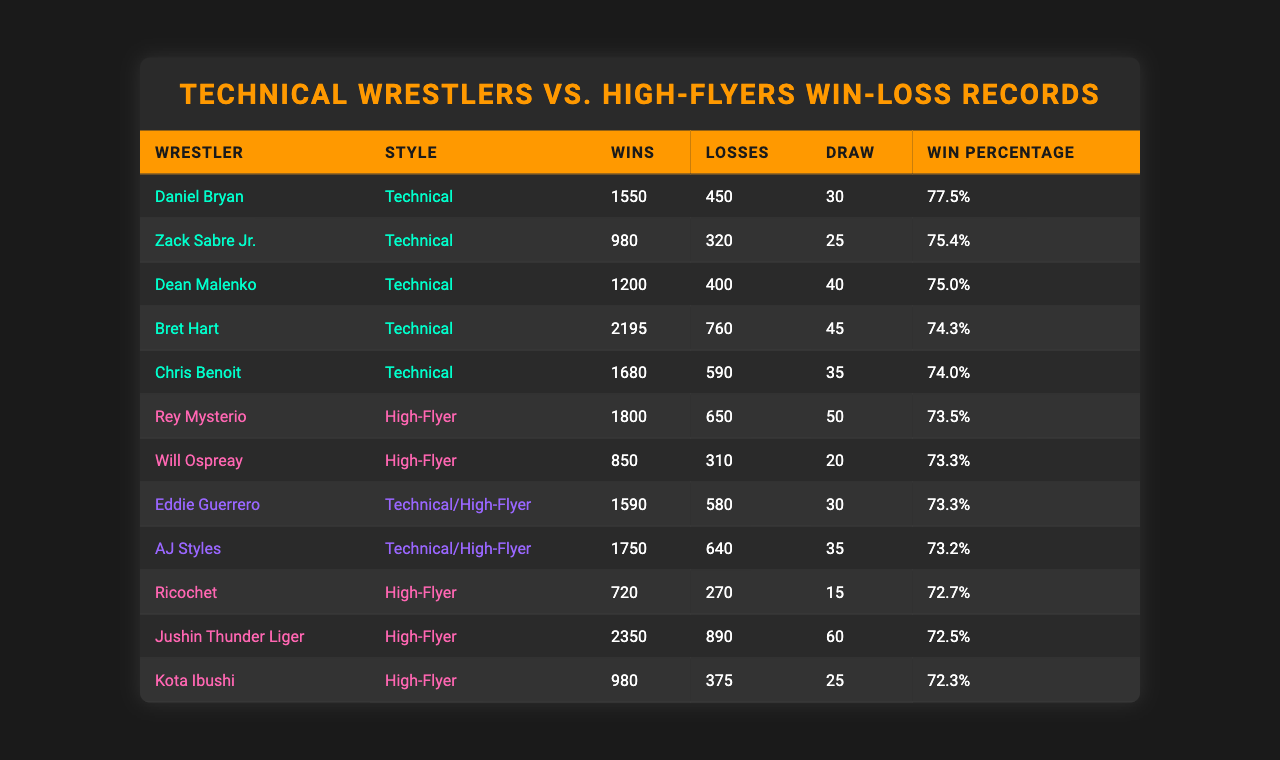What is the win percentage of Daniel Bryan? The table lists Daniel Bryan's win percentage as 77.5% under the "Win Percentage" column.
Answer: 77.5% Which wrestler has the highest number of losses? Jushin Thunder Liger has the highest number of losses at 890 as shown in the "Losses" column.
Answer: 890 Calculate the average win percentage of Technical wrestlers. The win percentages for Technical wrestlers are 77.5, 75.4, 75.0, 74.3, and 74.0. The sum is 376.2 and dividing by 5 gives an average of 75.24.
Answer: 75.24 Is the win percentage of high-flyers generally lower than that of technical wrestlers? Comparing the win percentages: Technical wrestlers have percentages mostly in the mid to high 70s while high-flyers are mostly in the low to mid 70s indicating low win percentages. Hence, it is generally true.
Answer: Yes If you combine the wins of all technical wrestlers, how many wins do they have in total? Adding the wins of all technical wrestlers: 1550 + 980 + 1200 + 2195 + 1680 = 8105 wins in total.
Answer: 8105 Who has a higher win-loss ratio, Bret Hart or Rey Mysterio? Bret Hart's win-loss ratio is calculated by dividing wins (2195) by losses (760), giving approximately 2.89. Rey Mysterio's win-loss ratio is 1800/650, approximately 2.77. Therefore, Bret Hart has a higher ratio.
Answer: Bret Hart What is the difference in the number of wins between the highest-rated technical wrestler and the highest-rated high-flyer? Daniel Bryan has the most wins among technical wrestlers with 1550, while Jushin Thunder Liger has the most wins among high-flyers with 2350. The difference is 2350 - 1550 = 800.
Answer: 800 Which wrestler has a win percentage closest to 75%? Eddie Guerrero and AJ Styles both have a win percentage of 73.3%, which is the closest to 75% among all wrestlers listed.
Answer: Eddie Guerrero and AJ Styles What percentage of total matches fought by Kota Ibushi ended in a loss? Kota Ibushi has 980 wins and 375 losses, giving a total of 980 + 375 = 1355 matches. The loss percentage is (375 / 1355) * 100 = approximately 27.65%.
Answer: 27.65% Which technical wrestler has the least number of wins? Zack Sabre Jr. has the least number of wins, with a total of 980 based on the data in the "Wins" column.
Answer: 980 